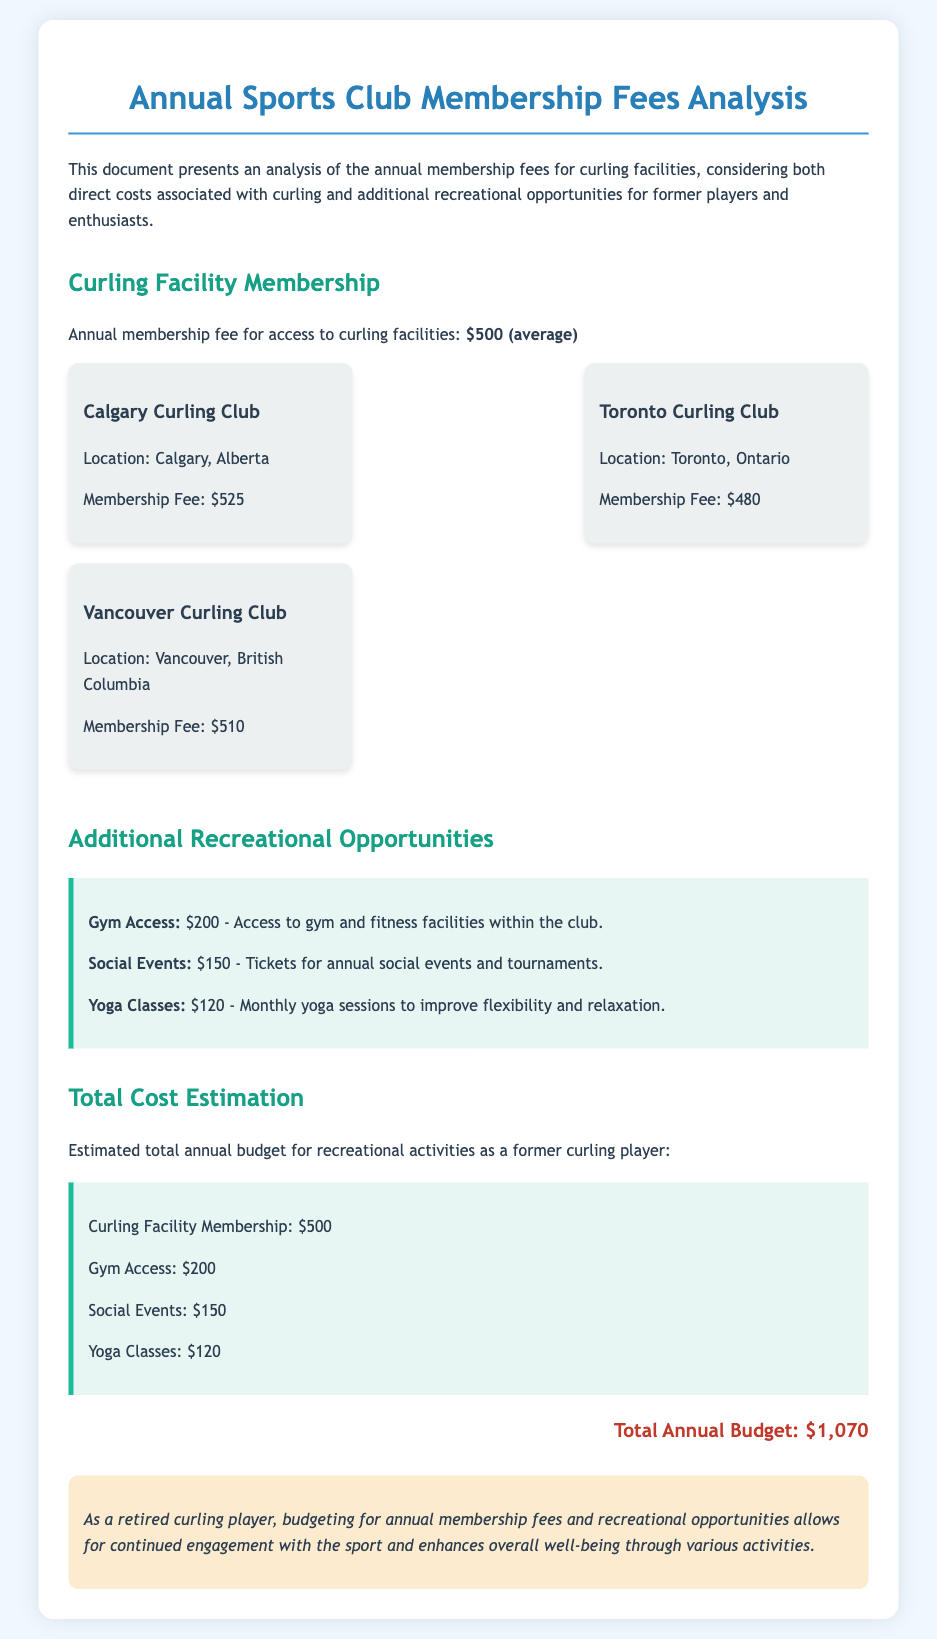What is the average annual membership fee for curling facilities? The document states that the average annual membership fee for access to curling facilities is $500.
Answer: $500 What is the membership fee for the Calgary Curling Club? The document lists that the membership fee for the Calgary Curling Club is $525.
Answer: $525 How much does gym access cost? According to the document, gym access costs $200.
Answer: $200 What is the total cost for yoga classes? The document specifies that yoga classes cost $120.
Answer: $120 Which curling club has the lowest membership fee? The document indicates that the Toronto Curling Club has the lowest membership fee at $480.
Answer: Toronto Curling Club What is the total annual budget for all recreational activities? The document calculates the total annual budget for recreational activities to be $1,070.
Answer: $1,070 How much do social events cost? The document states that tickets for social events cost $150.
Answer: $150 What are the total additional costs associated with recreational opportunities? The total additional costs for gym access, social events, and yoga classes sum up to $470 ($200 + $150 + $120).
Answer: $470 What is the conclusion drawn in the document? The document concludes that budgeting for annual membership fees and recreational opportunities enhances overall well-being.
Answer: Enhances overall well-being 